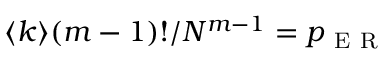<formula> <loc_0><loc_0><loc_500><loc_500>\langle k \rangle ( m - 1 ) ! / N ^ { m - 1 } = p _ { E R }</formula> 